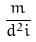Convert formula to latex. <formula><loc_0><loc_0><loc_500><loc_500>\frac { m } { d ^ { 2 } i }</formula> 